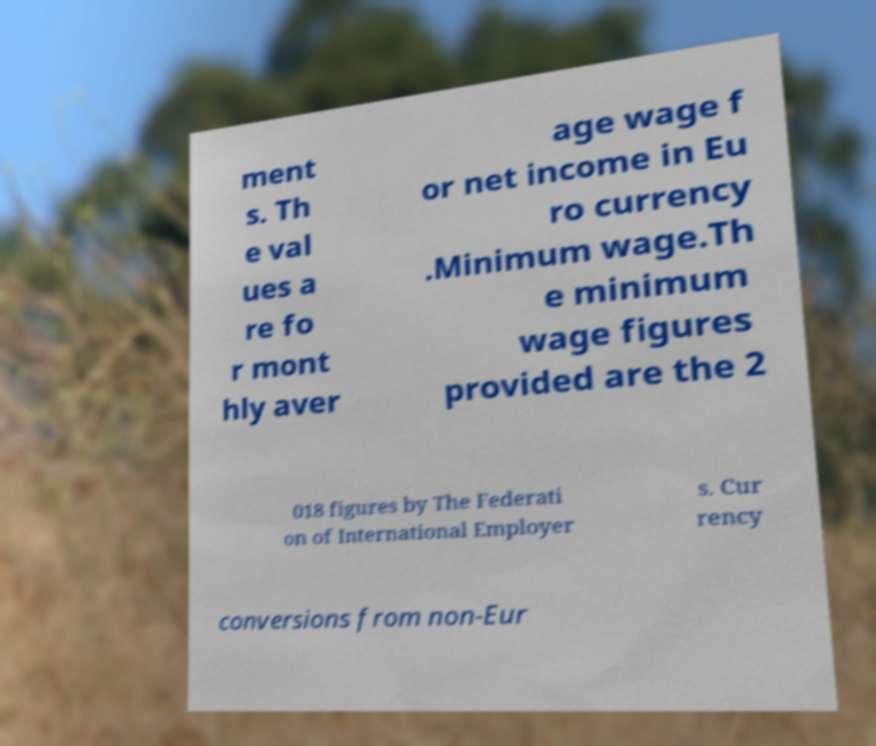Can you accurately transcribe the text from the provided image for me? ment s. Th e val ues a re fo r mont hly aver age wage f or net income in Eu ro currency .Minimum wage.Th e minimum wage figures provided are the 2 018 figures by The Federati on of International Employer s. Cur rency conversions from non-Eur 